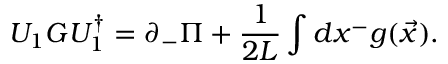<formula> <loc_0><loc_0><loc_500><loc_500>U _ { 1 } G U _ { 1 } ^ { \dagger } = \partial _ { - } \Pi + { \frac { 1 } { 2 L } } \int d x ^ { - } g ( { \vec { x } } ) .</formula> 